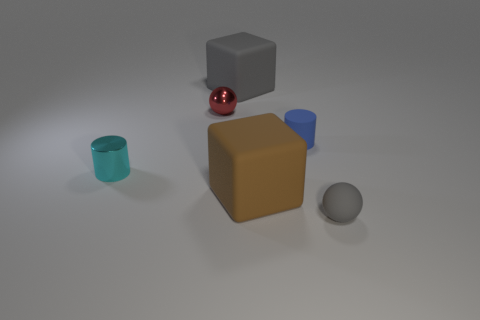Subtract all balls. How many objects are left? 4 Subtract all gray balls. How many balls are left? 1 Add 3 gray cubes. How many gray cubes are left? 4 Add 4 small brown blocks. How many small brown blocks exist? 4 Add 1 cyan cylinders. How many objects exist? 7 Subtract 0 cyan cubes. How many objects are left? 6 Subtract all purple blocks. Subtract all gray cylinders. How many blocks are left? 2 Subtract all green spheres. How many blue blocks are left? 0 Subtract all small gray things. Subtract all green blocks. How many objects are left? 5 